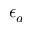<formula> <loc_0><loc_0><loc_500><loc_500>\epsilon _ { a }</formula> 